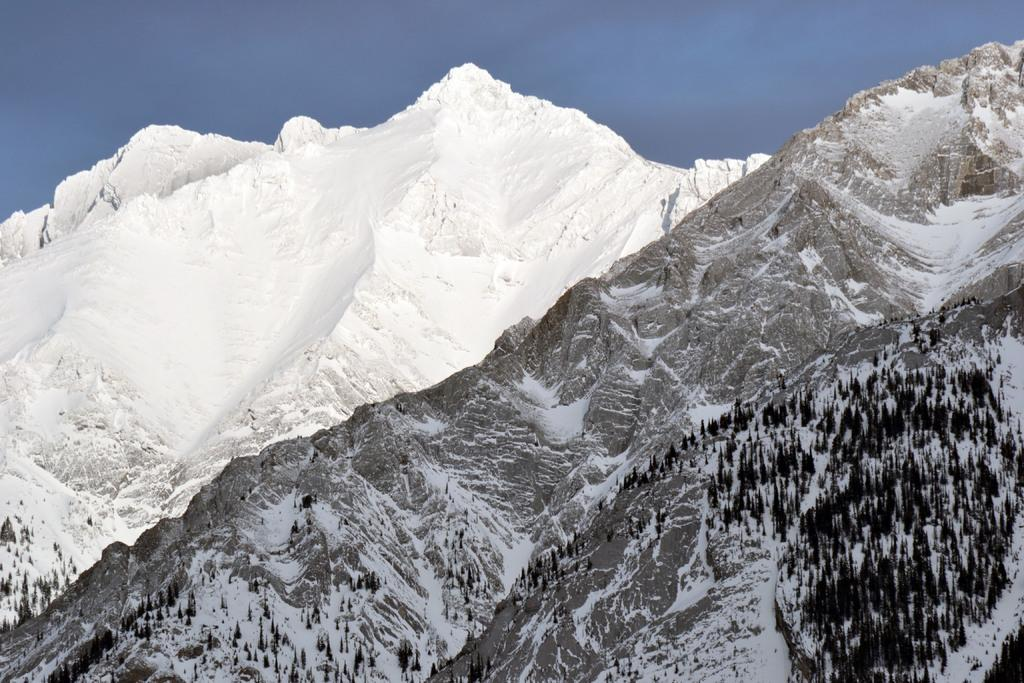What type of natural formation is present in the image? There are mountains in the image. What features can be observed on the mountains? The mountains have trees and snow. What can be seen in the background of the image? There is sky visible in the background of the image. Where is the hospital located in the image? There is no hospital present in the image; it features mountains with trees and snow. What type of town can be seen at the base of the mountains in the image? There is no town visible in the image; it only shows mountains with trees and snow. 